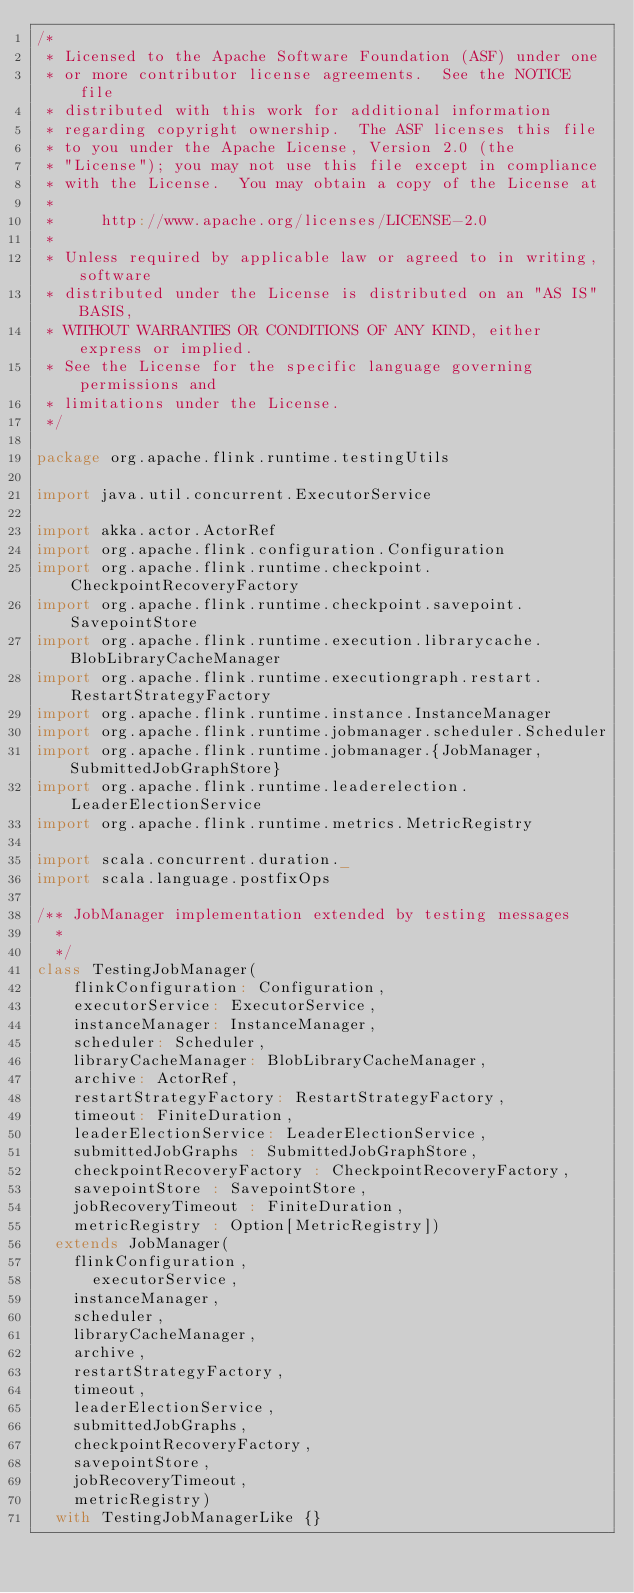<code> <loc_0><loc_0><loc_500><loc_500><_Scala_>/*
 * Licensed to the Apache Software Foundation (ASF) under one
 * or more contributor license agreements.  See the NOTICE file
 * distributed with this work for additional information
 * regarding copyright ownership.  The ASF licenses this file
 * to you under the Apache License, Version 2.0 (the
 * "License"); you may not use this file except in compliance
 * with the License.  You may obtain a copy of the License at
 *
 *     http://www.apache.org/licenses/LICENSE-2.0
 *
 * Unless required by applicable law or agreed to in writing, software
 * distributed under the License is distributed on an "AS IS" BASIS,
 * WITHOUT WARRANTIES OR CONDITIONS OF ANY KIND, either express or implied.
 * See the License for the specific language governing permissions and
 * limitations under the License.
 */

package org.apache.flink.runtime.testingUtils

import java.util.concurrent.ExecutorService

import akka.actor.ActorRef
import org.apache.flink.configuration.Configuration
import org.apache.flink.runtime.checkpoint.CheckpointRecoveryFactory
import org.apache.flink.runtime.checkpoint.savepoint.SavepointStore
import org.apache.flink.runtime.execution.librarycache.BlobLibraryCacheManager
import org.apache.flink.runtime.executiongraph.restart.RestartStrategyFactory
import org.apache.flink.runtime.instance.InstanceManager
import org.apache.flink.runtime.jobmanager.scheduler.Scheduler
import org.apache.flink.runtime.jobmanager.{JobManager, SubmittedJobGraphStore}
import org.apache.flink.runtime.leaderelection.LeaderElectionService
import org.apache.flink.runtime.metrics.MetricRegistry

import scala.concurrent.duration._
import scala.language.postfixOps

/** JobManager implementation extended by testing messages
  *
  */
class TestingJobManager(
    flinkConfiguration: Configuration,
    executorService: ExecutorService,
    instanceManager: InstanceManager,
    scheduler: Scheduler,
    libraryCacheManager: BlobLibraryCacheManager,
    archive: ActorRef,
    restartStrategyFactory: RestartStrategyFactory,
    timeout: FiniteDuration,
    leaderElectionService: LeaderElectionService,
    submittedJobGraphs : SubmittedJobGraphStore,
    checkpointRecoveryFactory : CheckpointRecoveryFactory,
    savepointStore : SavepointStore,
    jobRecoveryTimeout : FiniteDuration,
    metricRegistry : Option[MetricRegistry])
  extends JobManager(
    flinkConfiguration,
      executorService,
    instanceManager,
    scheduler,
    libraryCacheManager,
    archive,
    restartStrategyFactory,
    timeout,
    leaderElectionService,
    submittedJobGraphs,
    checkpointRecoveryFactory,
    savepointStore,
    jobRecoveryTimeout,
    metricRegistry)
  with TestingJobManagerLike {}
</code> 